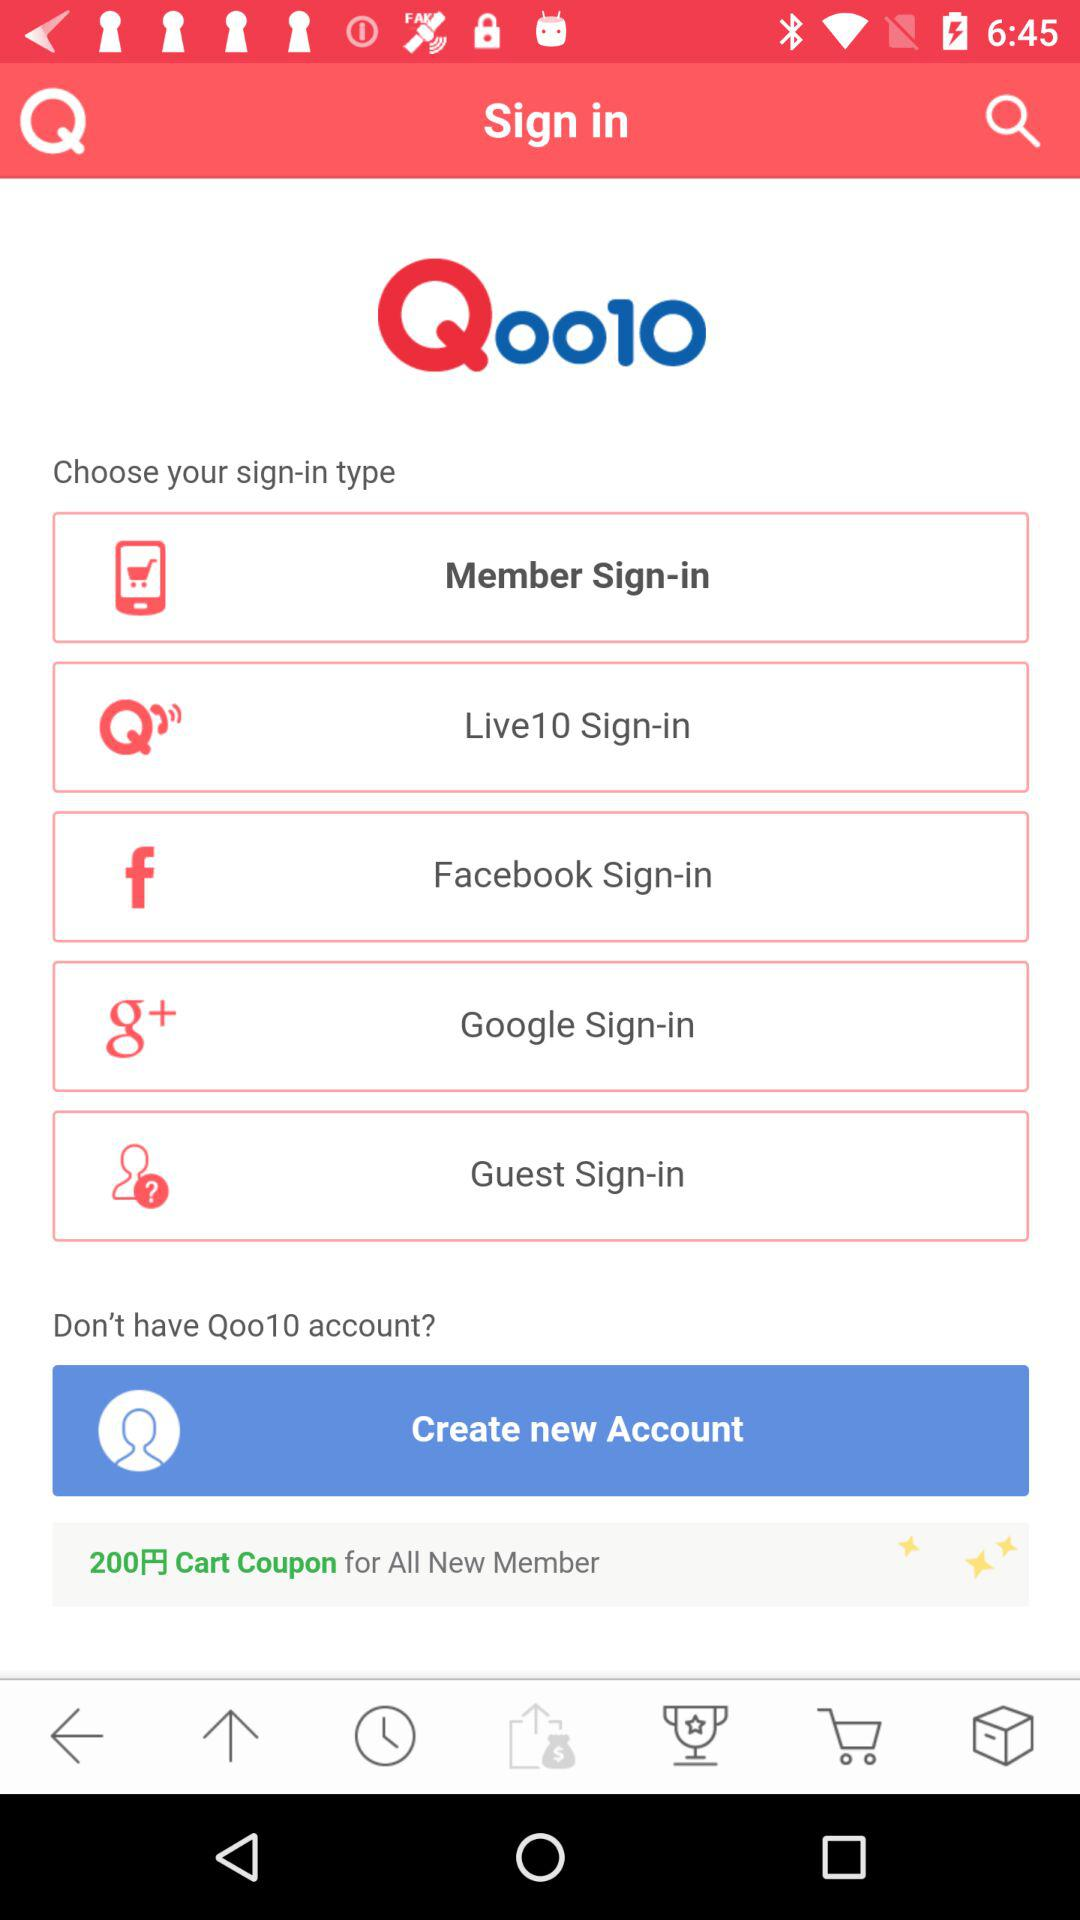How many sign-in options are there?
Answer the question using a single word or phrase. 5 